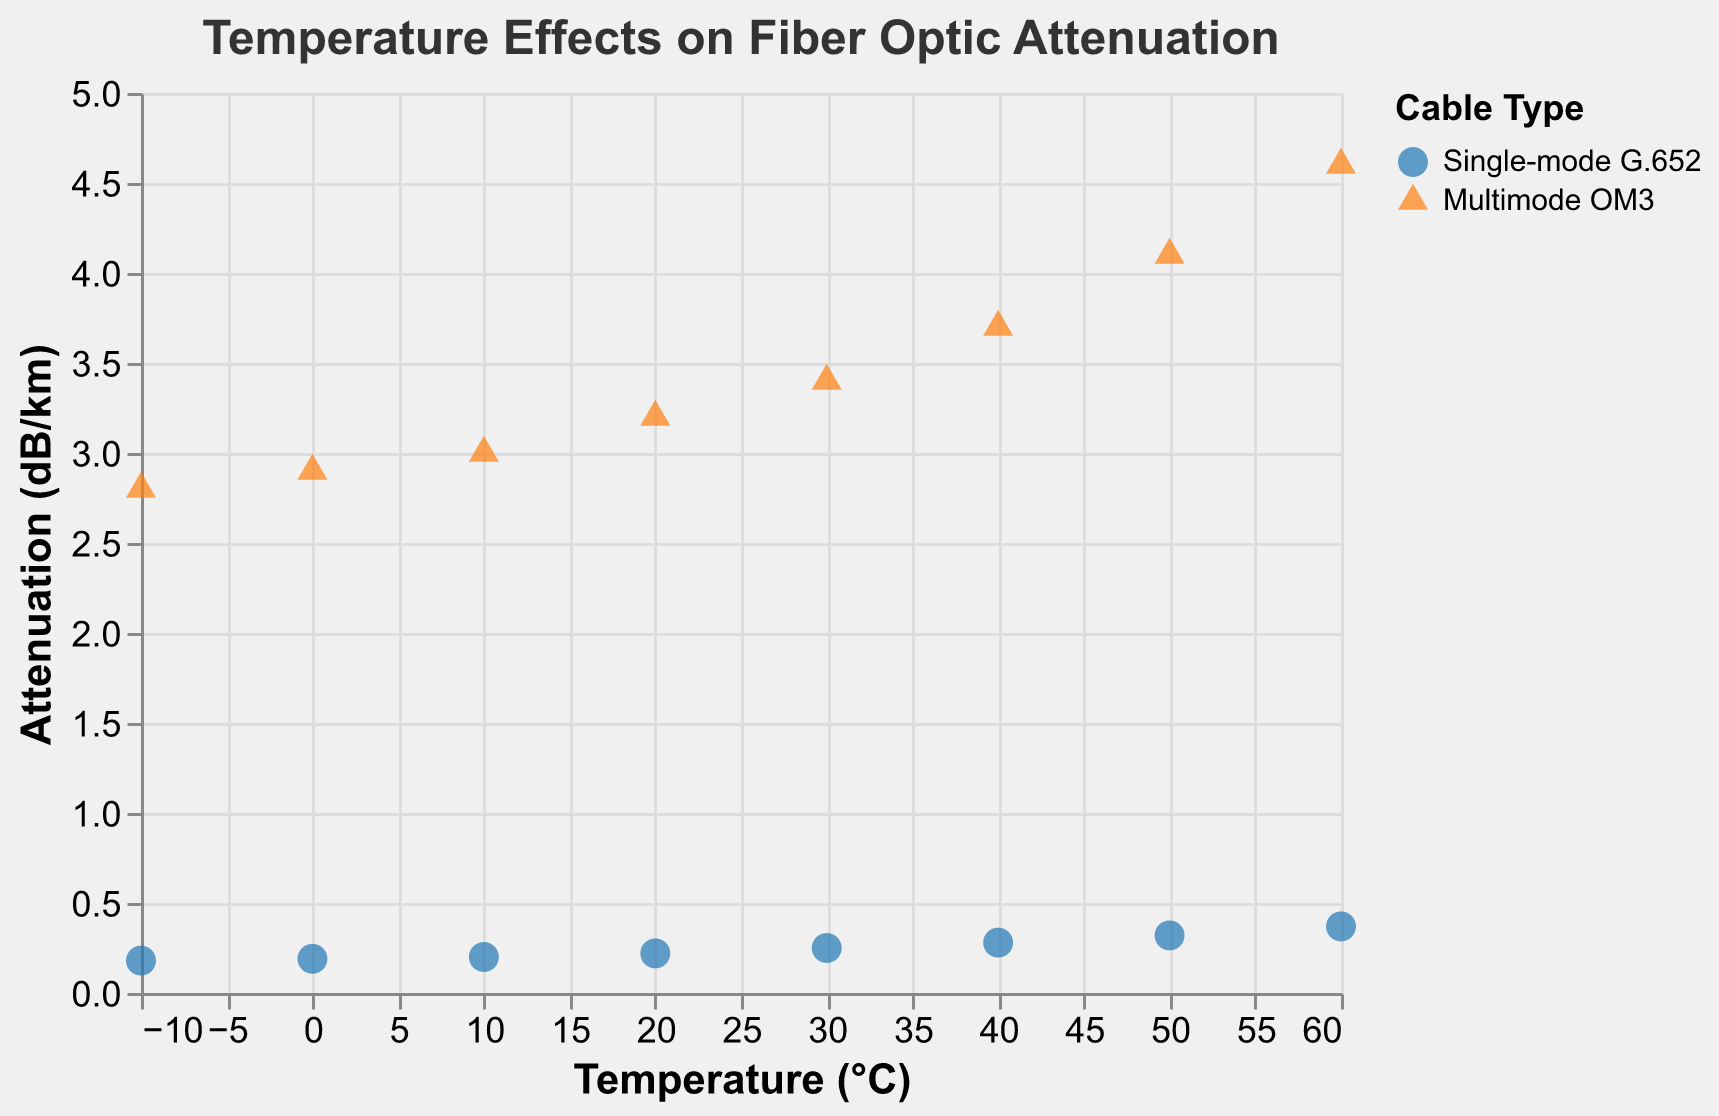What is the title of the figure? The title is displayed at the top of the figure and reads "Temperature Effects on Fiber Optic Attenuation."
Answer: Temperature Effects on Fiber Optic Attenuation How many different cable types are shown in the figure? The legend of the figure displays two different cable types, distinguished by color and shape: "Single-mode G.652" and "Multimode OM3."
Answer: 2 What is the highest attenuation value and at which temperature does it occur? The highest attenuation value is for "Multimode OM3" at 4.6 dB/km, occurring at 60°C. This can be identified by locating the uppermost point on the Y-axis for "Multimode OM3."
Answer: 4.6 dB/km at 60°C Which cable type has a lower attenuation rate overall? By comparing the points on the Y-axis for both cable types across all temperature points, "Single-mode G.652" consistently shows lower attenuation rates compared to "Multimode OM3."
Answer: Single-mode G.652 At 20°C, what is the difference in attenuation between the two cable types? At 20°C, the attenuation for "Single-mode G.652" is 0.22 dB/km, and for "Multimode OM3" it is 3.2 dB/km. The difference is calculated as 3.2 - 0.22.
Answer: 2.98 dB/km How does the attenuation for Single-mode G.652 change from -10°C to 60°C? The attenuation values for "Single-mode G.652" increase from 0.18 dB/km at -10°C to 0.37 dB/km at 60°C. This change is calculated as 0.37 - 0.18.
Answer: 0.19 dB/km What is the trend of attenuation for Multimode OM3 as temperature increases? The attenuation for "Multimode OM3" increases as temperature rises, starting from 2.8 dB/km at -10°C and reaching 4.6 dB/km at 60°C. This is observed by the upward trend in data points.
Answer: Increasing What is the average attenuation rate of Single-mode G.652 across all temperatures? The attenuation rates for "Single-mode G.652" are: 0.18, 0.19, 0.20, 0.22, 0.25, 0.28, 0.32, and 0.37. Summing these values gives 2.01, and the average is 2.01 / 8.
Answer: 0.25125 dB/km Which cable type shows a steeper increase in attenuation rate with temperature? By comparing the changes in attenuation rates for both cable types across various temperature points, "Multimode OM3" displays a steeper increase (from 2.8 to 4.6) compared to "Single-mode G.652" (from 0.18 to 0.37).
Answer: Multimode OM3 At 30°C, do the attenuation rates of the two cable types differ by more than 3 dB/km? At 30°C, the attenuation rates are 0.25 dB/km for "Single-mode G.652" and 3.4 dB/km for "Multimode OM3." The difference is calculated as 3.4 - 0.25.
Answer: Yes, by 3.15 dB/km 